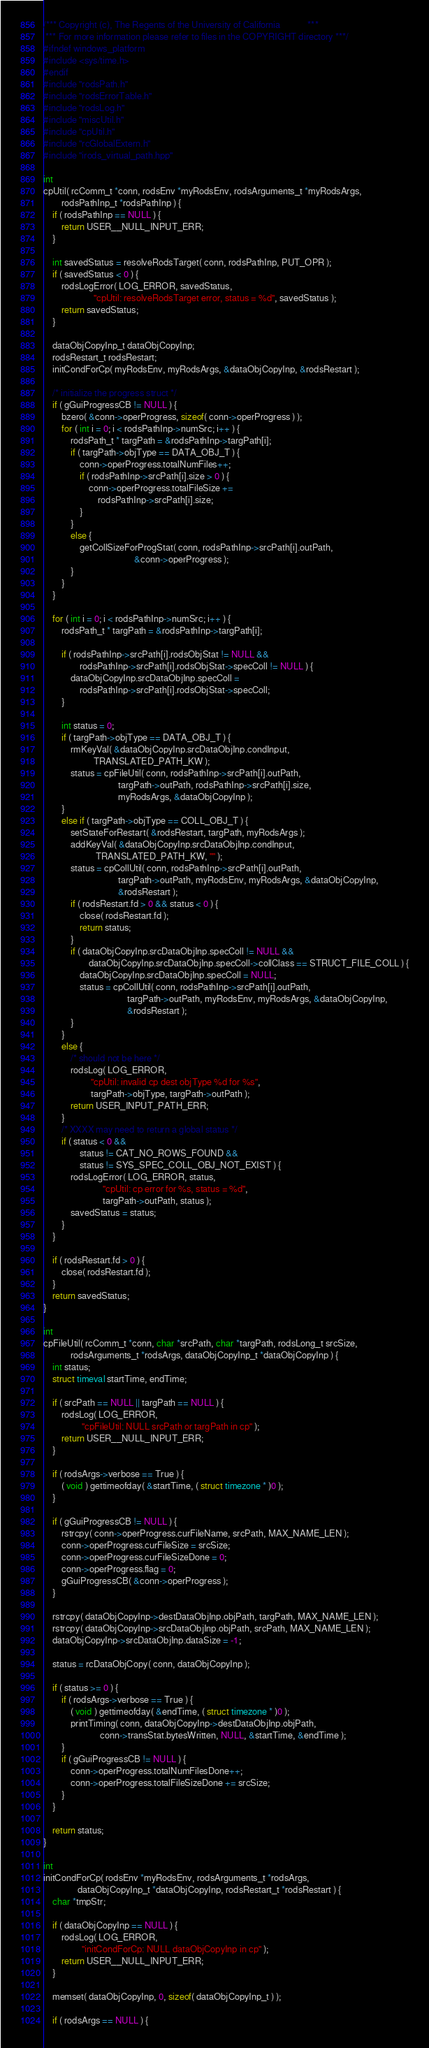Convert code to text. <code><loc_0><loc_0><loc_500><loc_500><_C++_>/*** Copyright (c), The Regents of the University of California            ***
 *** For more information please refer to files in the COPYRIGHT directory ***/
#ifndef windows_platform
#include <sys/time.h>
#endif
#include "rodsPath.h"
#include "rodsErrorTable.h"
#include "rodsLog.h"
#include "miscUtil.h"
#include "cpUtil.h"
#include "rcGlobalExtern.h"
#include "irods_virtual_path.hpp"

int
cpUtil( rcComm_t *conn, rodsEnv *myRodsEnv, rodsArguments_t *myRodsArgs,
        rodsPathInp_t *rodsPathInp ) {
    if ( rodsPathInp == NULL ) {
        return USER__NULL_INPUT_ERR;
    }

    int savedStatus = resolveRodsTarget( conn, rodsPathInp, PUT_OPR );
    if ( savedStatus < 0 ) {
        rodsLogError( LOG_ERROR, savedStatus,
                      "cpUtil: resolveRodsTarget error, status = %d", savedStatus );
        return savedStatus;
    }

    dataObjCopyInp_t dataObjCopyInp;
    rodsRestart_t rodsRestart;
    initCondForCp( myRodsEnv, myRodsArgs, &dataObjCopyInp, &rodsRestart );

    /* initialize the progress struct */
    if ( gGuiProgressCB != NULL ) {
        bzero( &conn->operProgress, sizeof( conn->operProgress ) );
        for ( int i = 0; i < rodsPathInp->numSrc; i++ ) {
            rodsPath_t * targPath = &rodsPathInp->targPath[i];
            if ( targPath->objType == DATA_OBJ_T ) {
                conn->operProgress.totalNumFiles++;
                if ( rodsPathInp->srcPath[i].size > 0 ) {
                    conn->operProgress.totalFileSize +=
                        rodsPathInp->srcPath[i].size;
                }
            }
            else {
                getCollSizeForProgStat( conn, rodsPathInp->srcPath[i].outPath,
                                        &conn->operProgress );
            }
        }
    }

    for ( int i = 0; i < rodsPathInp->numSrc; i++ ) {
        rodsPath_t * targPath = &rodsPathInp->targPath[i];

        if ( rodsPathInp->srcPath[i].rodsObjStat != NULL &&
                rodsPathInp->srcPath[i].rodsObjStat->specColl != NULL ) {
            dataObjCopyInp.srcDataObjInp.specColl =
                rodsPathInp->srcPath[i].rodsObjStat->specColl;
        }

        int status = 0;
        if ( targPath->objType == DATA_OBJ_T ) {
            rmKeyVal( &dataObjCopyInp.srcDataObjInp.condInput,
                      TRANSLATED_PATH_KW );
            status = cpFileUtil( conn, rodsPathInp->srcPath[i].outPath,
                                 targPath->outPath, rodsPathInp->srcPath[i].size,
                                 myRodsArgs, &dataObjCopyInp );
        }
        else if ( targPath->objType == COLL_OBJ_T ) {
            setStateForRestart( &rodsRestart, targPath, myRodsArgs );
            addKeyVal( &dataObjCopyInp.srcDataObjInp.condInput,
                       TRANSLATED_PATH_KW, "" );
            status = cpCollUtil( conn, rodsPathInp->srcPath[i].outPath,
                                 targPath->outPath, myRodsEnv, myRodsArgs, &dataObjCopyInp,
                                 &rodsRestart );
            if ( rodsRestart.fd > 0 && status < 0 ) {
                close( rodsRestart.fd );
                return status;
            }
            if ( dataObjCopyInp.srcDataObjInp.specColl != NULL &&
                    dataObjCopyInp.srcDataObjInp.specColl->collClass == STRUCT_FILE_COLL ) {
                dataObjCopyInp.srcDataObjInp.specColl = NULL;
                status = cpCollUtil( conn, rodsPathInp->srcPath[i].outPath,
                                     targPath->outPath, myRodsEnv, myRodsArgs, &dataObjCopyInp,
                                     &rodsRestart );
            }
        }
        else {
            /* should not be here */
            rodsLog( LOG_ERROR,
                     "cpUtil: invalid cp dest objType %d for %s",
                     targPath->objType, targPath->outPath );
            return USER_INPUT_PATH_ERR;
        }
        /* XXXX may need to return a global status */
        if ( status < 0 &&
                status != CAT_NO_ROWS_FOUND &&
                status != SYS_SPEC_COLL_OBJ_NOT_EXIST ) {
            rodsLogError( LOG_ERROR, status,
                          "cpUtil: cp error for %s, status = %d",
                          targPath->outPath, status );
            savedStatus = status;
        }
    }

    if ( rodsRestart.fd > 0 ) {
        close( rodsRestart.fd );
    }
    return savedStatus;
}

int
cpFileUtil( rcComm_t *conn, char *srcPath, char *targPath, rodsLong_t srcSize,
            rodsArguments_t *rodsArgs, dataObjCopyInp_t *dataObjCopyInp ) {
    int status;
    struct timeval startTime, endTime;

    if ( srcPath == NULL || targPath == NULL ) {
        rodsLog( LOG_ERROR,
                 "cpFileUtil: NULL srcPath or targPath in cp" );
        return USER__NULL_INPUT_ERR;
    }

    if ( rodsArgs->verbose == True ) {
        ( void ) gettimeofday( &startTime, ( struct timezone * )0 );
    }

    if ( gGuiProgressCB != NULL ) {
        rstrcpy( conn->operProgress.curFileName, srcPath, MAX_NAME_LEN );
        conn->operProgress.curFileSize = srcSize;
        conn->operProgress.curFileSizeDone = 0;
        conn->operProgress.flag = 0;
        gGuiProgressCB( &conn->operProgress );
    }

    rstrcpy( dataObjCopyInp->destDataObjInp.objPath, targPath, MAX_NAME_LEN );
    rstrcpy( dataObjCopyInp->srcDataObjInp.objPath, srcPath, MAX_NAME_LEN );
    dataObjCopyInp->srcDataObjInp.dataSize = -1;

    status = rcDataObjCopy( conn, dataObjCopyInp );

    if ( status >= 0 ) {
        if ( rodsArgs->verbose == True ) {
            ( void ) gettimeofday( &endTime, ( struct timezone * )0 );
            printTiming( conn, dataObjCopyInp->destDataObjInp.objPath,
                         conn->transStat.bytesWritten, NULL, &startTime, &endTime );
        }
        if ( gGuiProgressCB != NULL ) {
            conn->operProgress.totalNumFilesDone++;
            conn->operProgress.totalFileSizeDone += srcSize;
        }
    }

    return status;
}

int
initCondForCp( rodsEnv *myRodsEnv, rodsArguments_t *rodsArgs,
               dataObjCopyInp_t *dataObjCopyInp, rodsRestart_t *rodsRestart ) {
    char *tmpStr;

    if ( dataObjCopyInp == NULL ) {
        rodsLog( LOG_ERROR,
                 "initCondForCp: NULL dataObjCopyInp in cp" );
        return USER__NULL_INPUT_ERR;
    }

    memset( dataObjCopyInp, 0, sizeof( dataObjCopyInp_t ) );

    if ( rodsArgs == NULL ) {</code> 